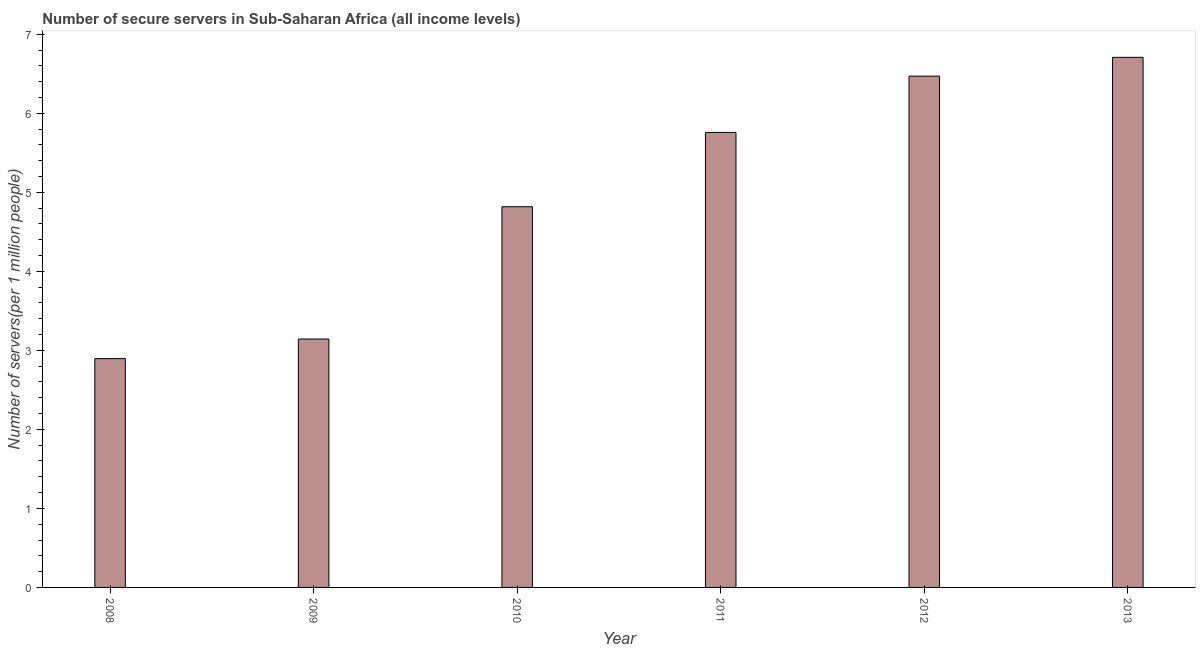Does the graph contain grids?
Offer a terse response. No. What is the title of the graph?
Offer a very short reply. Number of secure servers in Sub-Saharan Africa (all income levels). What is the label or title of the Y-axis?
Your answer should be compact. Number of servers(per 1 million people). What is the number of secure internet servers in 2008?
Offer a very short reply. 2.9. Across all years, what is the maximum number of secure internet servers?
Provide a succinct answer. 6.71. Across all years, what is the minimum number of secure internet servers?
Your answer should be compact. 2.9. What is the sum of the number of secure internet servers?
Ensure brevity in your answer.  29.79. What is the difference between the number of secure internet servers in 2011 and 2013?
Keep it short and to the point. -0.95. What is the average number of secure internet servers per year?
Give a very brief answer. 4.96. What is the median number of secure internet servers?
Keep it short and to the point. 5.29. Do a majority of the years between 2013 and 2012 (inclusive) have number of secure internet servers greater than 4.8 ?
Keep it short and to the point. No. What is the ratio of the number of secure internet servers in 2008 to that in 2010?
Your answer should be very brief. 0.6. Is the number of secure internet servers in 2008 less than that in 2009?
Provide a short and direct response. Yes. Is the difference between the number of secure internet servers in 2009 and 2013 greater than the difference between any two years?
Offer a very short reply. No. What is the difference between the highest and the second highest number of secure internet servers?
Your answer should be compact. 0.24. What is the difference between the highest and the lowest number of secure internet servers?
Offer a terse response. 3.81. How many bars are there?
Ensure brevity in your answer.  6. How many years are there in the graph?
Offer a very short reply. 6. What is the difference between two consecutive major ticks on the Y-axis?
Provide a short and direct response. 1. Are the values on the major ticks of Y-axis written in scientific E-notation?
Provide a short and direct response. No. What is the Number of servers(per 1 million people) of 2008?
Ensure brevity in your answer.  2.9. What is the Number of servers(per 1 million people) in 2009?
Provide a succinct answer. 3.14. What is the Number of servers(per 1 million people) in 2010?
Provide a short and direct response. 4.82. What is the Number of servers(per 1 million people) of 2011?
Your answer should be compact. 5.76. What is the Number of servers(per 1 million people) in 2012?
Provide a short and direct response. 6.47. What is the Number of servers(per 1 million people) in 2013?
Provide a short and direct response. 6.71. What is the difference between the Number of servers(per 1 million people) in 2008 and 2009?
Keep it short and to the point. -0.25. What is the difference between the Number of servers(per 1 million people) in 2008 and 2010?
Make the answer very short. -1.92. What is the difference between the Number of servers(per 1 million people) in 2008 and 2011?
Ensure brevity in your answer.  -2.86. What is the difference between the Number of servers(per 1 million people) in 2008 and 2012?
Give a very brief answer. -3.57. What is the difference between the Number of servers(per 1 million people) in 2008 and 2013?
Offer a terse response. -3.81. What is the difference between the Number of servers(per 1 million people) in 2009 and 2010?
Offer a terse response. -1.67. What is the difference between the Number of servers(per 1 million people) in 2009 and 2011?
Provide a succinct answer. -2.61. What is the difference between the Number of servers(per 1 million people) in 2009 and 2012?
Provide a succinct answer. -3.33. What is the difference between the Number of servers(per 1 million people) in 2009 and 2013?
Keep it short and to the point. -3.56. What is the difference between the Number of servers(per 1 million people) in 2010 and 2011?
Provide a short and direct response. -0.94. What is the difference between the Number of servers(per 1 million people) in 2010 and 2012?
Offer a very short reply. -1.65. What is the difference between the Number of servers(per 1 million people) in 2010 and 2013?
Offer a terse response. -1.89. What is the difference between the Number of servers(per 1 million people) in 2011 and 2012?
Your answer should be compact. -0.71. What is the difference between the Number of servers(per 1 million people) in 2011 and 2013?
Your response must be concise. -0.95. What is the difference between the Number of servers(per 1 million people) in 2012 and 2013?
Your response must be concise. -0.24. What is the ratio of the Number of servers(per 1 million people) in 2008 to that in 2009?
Make the answer very short. 0.92. What is the ratio of the Number of servers(per 1 million people) in 2008 to that in 2010?
Offer a very short reply. 0.6. What is the ratio of the Number of servers(per 1 million people) in 2008 to that in 2011?
Provide a succinct answer. 0.5. What is the ratio of the Number of servers(per 1 million people) in 2008 to that in 2012?
Provide a succinct answer. 0.45. What is the ratio of the Number of servers(per 1 million people) in 2008 to that in 2013?
Provide a short and direct response. 0.43. What is the ratio of the Number of servers(per 1 million people) in 2009 to that in 2010?
Provide a succinct answer. 0.65. What is the ratio of the Number of servers(per 1 million people) in 2009 to that in 2011?
Your response must be concise. 0.55. What is the ratio of the Number of servers(per 1 million people) in 2009 to that in 2012?
Provide a short and direct response. 0.49. What is the ratio of the Number of servers(per 1 million people) in 2009 to that in 2013?
Give a very brief answer. 0.47. What is the ratio of the Number of servers(per 1 million people) in 2010 to that in 2011?
Keep it short and to the point. 0.84. What is the ratio of the Number of servers(per 1 million people) in 2010 to that in 2012?
Your response must be concise. 0.74. What is the ratio of the Number of servers(per 1 million people) in 2010 to that in 2013?
Your answer should be very brief. 0.72. What is the ratio of the Number of servers(per 1 million people) in 2011 to that in 2012?
Your answer should be compact. 0.89. What is the ratio of the Number of servers(per 1 million people) in 2011 to that in 2013?
Provide a short and direct response. 0.86. 